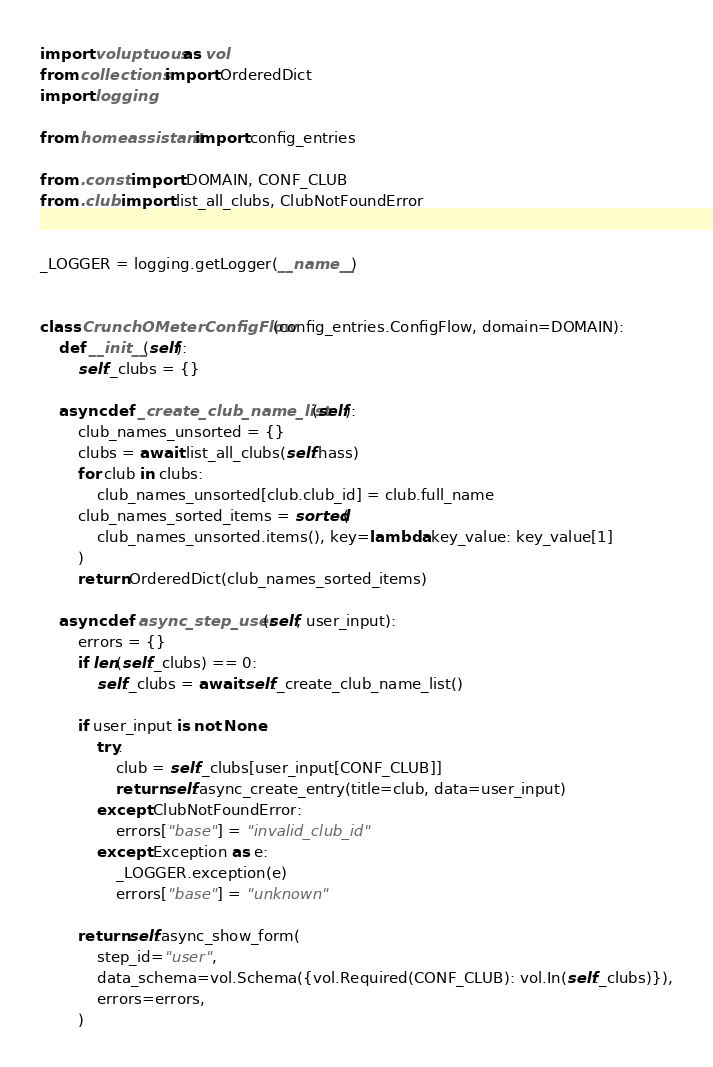Convert code to text. <code><loc_0><loc_0><loc_500><loc_500><_Python_>import voluptuous as vol
from collections import OrderedDict
import logging

from homeassistant import config_entries

from .const import DOMAIN, CONF_CLUB
from .club import list_all_clubs, ClubNotFoundError


_LOGGER = logging.getLogger(__name__)


class CrunchOMeterConfigFlow(config_entries.ConfigFlow, domain=DOMAIN):
    def __init__(self):
        self._clubs = {}

    async def _create_club_name_list(self):
        club_names_unsorted = {}
        clubs = await list_all_clubs(self.hass)
        for club in clubs:
            club_names_unsorted[club.club_id] = club.full_name
        club_names_sorted_items = sorted(
            club_names_unsorted.items(), key=lambda key_value: key_value[1]
        )
        return OrderedDict(club_names_sorted_items)

    async def async_step_user(self, user_input):
        errors = {}
        if len(self._clubs) == 0:
            self._clubs = await self._create_club_name_list()

        if user_input is not None:
            try:
                club = self._clubs[user_input[CONF_CLUB]]
                return self.async_create_entry(title=club, data=user_input)
            except ClubNotFoundError:
                errors["base"] = "invalid_club_id"
            except Exception as e:
                _LOGGER.exception(e)
                errors["base"] = "unknown"

        return self.async_show_form(
            step_id="user",
            data_schema=vol.Schema({vol.Required(CONF_CLUB): vol.In(self._clubs)}),
            errors=errors,
        )
</code> 